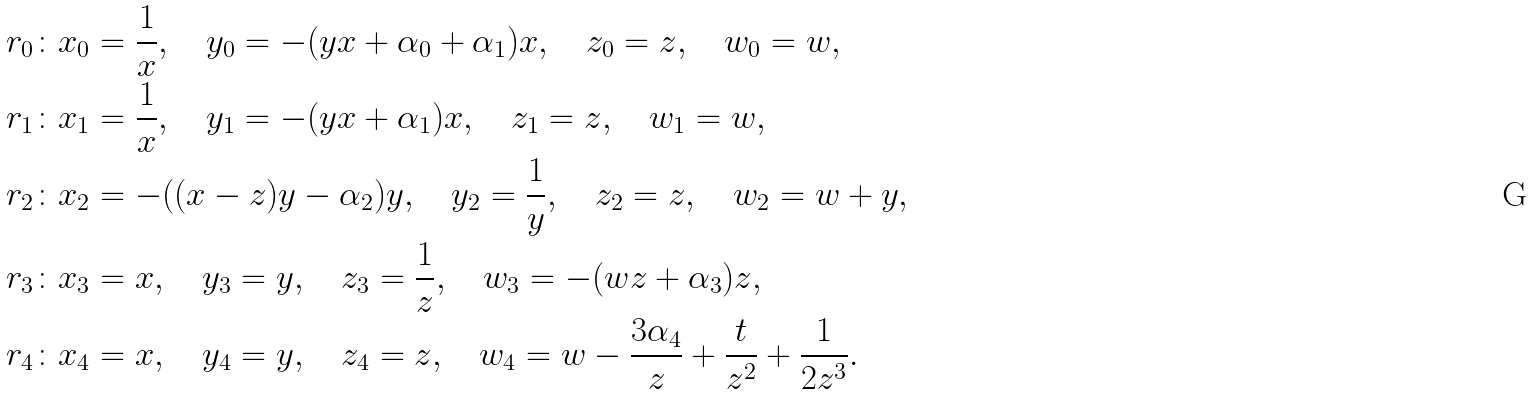Convert formula to latex. <formula><loc_0><loc_0><loc_500><loc_500>r _ { 0 } \colon & x _ { 0 } = \frac { 1 } { x } , \quad y _ { 0 } = - ( y x + \alpha _ { 0 } + \alpha _ { 1 } ) x , \quad z _ { 0 } = z , \quad w _ { 0 } = w , \\ r _ { 1 } \colon & x _ { 1 } = \frac { 1 } { x } , \quad y _ { 1 } = - ( y x + \alpha _ { 1 } ) x , \quad z _ { 1 } = z , \quad w _ { 1 } = w , \\ r _ { 2 } \colon & x _ { 2 } = - ( ( x - z ) y - \alpha _ { 2 } ) y , \quad y _ { 2 } = \frac { 1 } { y } , \quad z _ { 2 } = z , \quad w _ { 2 } = w + y , \\ r _ { 3 } \colon & x _ { 3 } = x , \quad y _ { 3 } = y , \quad z _ { 3 } = \frac { 1 } { z } , \quad w _ { 3 } = - ( w z + \alpha _ { 3 } ) z , \\ r _ { 4 } \colon & x _ { 4 } = x , \quad y _ { 4 } = y , \quad z _ { 4 } = z , \quad w _ { 4 } = w - \frac { 3 \alpha _ { 4 } } { z } + \frac { t } { z ^ { 2 } } + \frac { 1 } { 2 z ^ { 3 } } .</formula> 